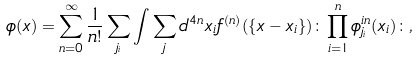<formula> <loc_0><loc_0><loc_500><loc_500>\phi ( x ) = \sum _ { n = 0 } ^ { \infty } \frac { 1 } { n ! } \sum _ { j _ { i } } \int \sum _ { j } d ^ { 4 n } x _ { i } f ^ { ( n ) } ( \{ x - x _ { i } \} ) \colon \prod _ { i = 1 } ^ { n } \phi _ { j _ { i } } ^ { i n } ( x _ { i } ) \colon ,</formula> 